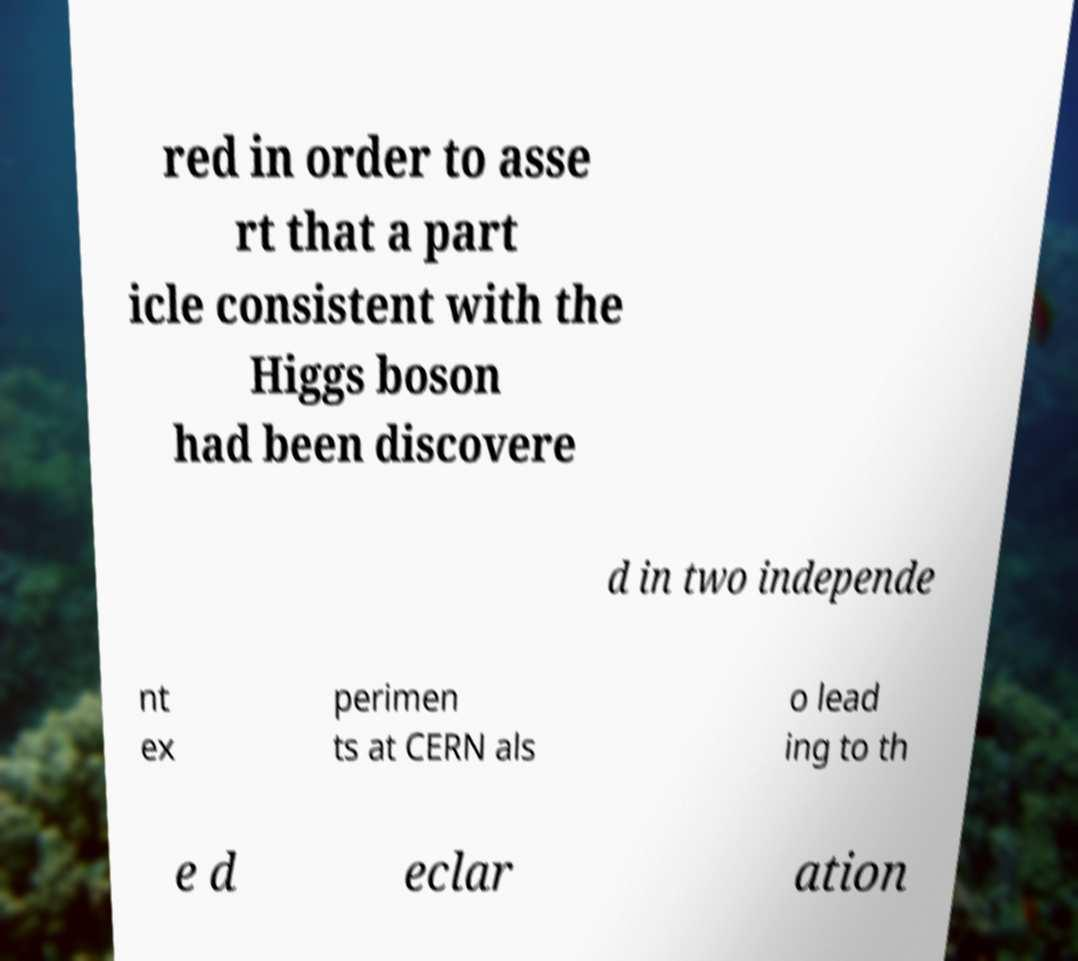Can you read and provide the text displayed in the image?This photo seems to have some interesting text. Can you extract and type it out for me? red in order to asse rt that a part icle consistent with the Higgs boson had been discovere d in two independe nt ex perimen ts at CERN als o lead ing to th e d eclar ation 